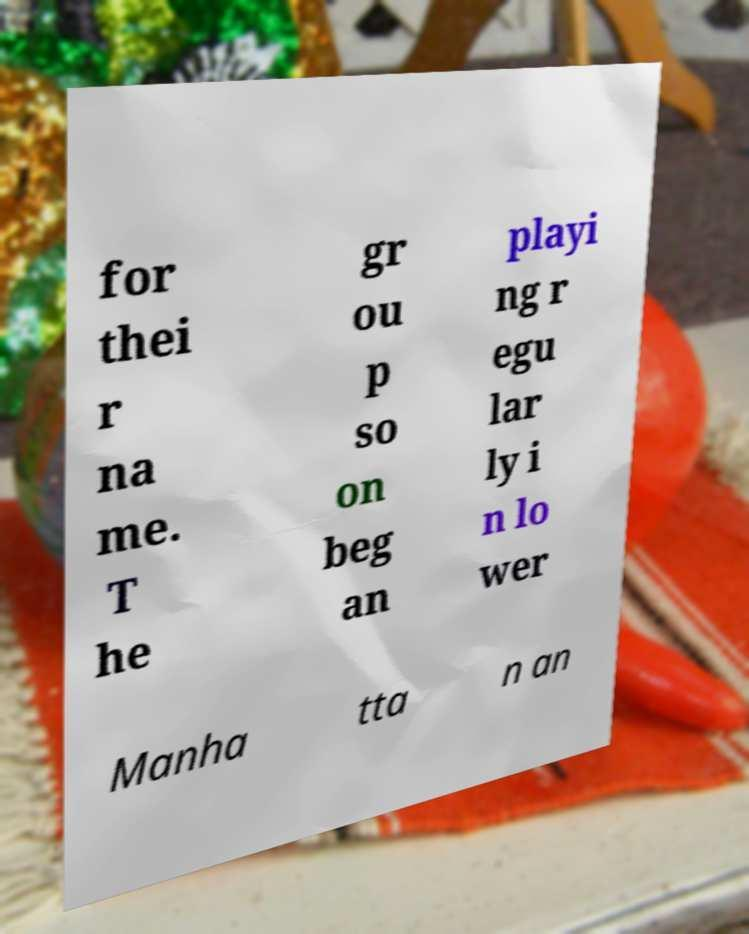Could you assist in decoding the text presented in this image and type it out clearly? for thei r na me. T he gr ou p so on beg an playi ng r egu lar ly i n lo wer Manha tta n an 